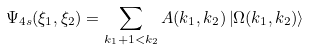<formula> <loc_0><loc_0><loc_500><loc_500>\Psi _ { 4 s } ( \xi _ { 1 } , \xi _ { 2 } ) = \sum _ { k _ { 1 } + 1 < k _ { 2 } } A ( k _ { 1 } , k _ { 2 } ) \left | \Omega ( k _ { 1 } , k _ { 2 } ) \right \rangle</formula> 